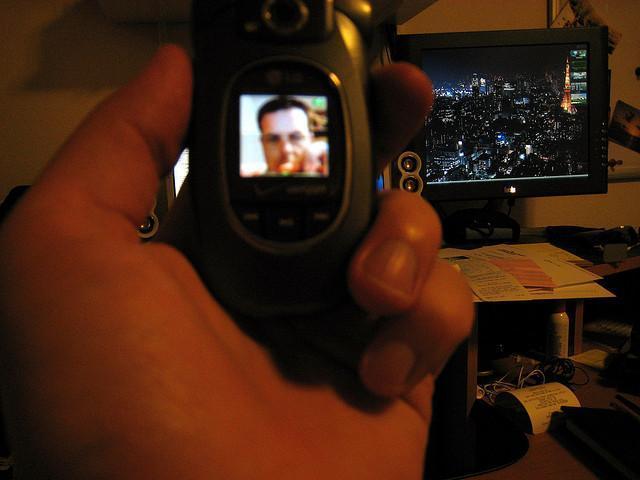How many people are in the picture?
Give a very brief answer. 2. 